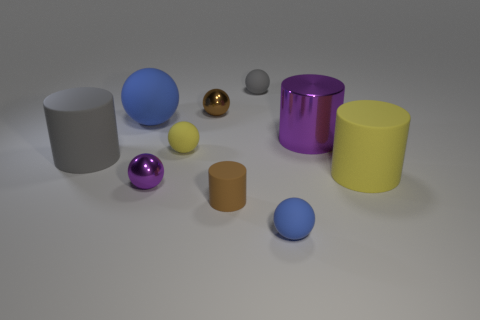What number of other things are the same material as the purple sphere?
Your answer should be compact. 2. The brown thing in front of the gray rubber thing left of the metallic object that is in front of the large yellow matte object is what shape?
Your answer should be very brief. Cylinder. Is the number of big gray matte cylinders on the right side of the tiny rubber cylinder less than the number of large cylinders that are behind the small yellow rubber ball?
Provide a succinct answer. Yes. Are there any big objects that have the same color as the metallic cylinder?
Provide a short and direct response. No. Is the material of the small cylinder the same as the small ball behind the tiny brown metal ball?
Your response must be concise. Yes. There is a matte cylinder on the right side of the small blue ball; are there any large purple things right of it?
Your answer should be compact. No. The small thing that is left of the small gray rubber ball and in front of the tiny purple metallic ball is what color?
Your answer should be compact. Brown. The purple ball has what size?
Provide a succinct answer. Small. What number of yellow cylinders are the same size as the yellow rubber ball?
Provide a short and direct response. 0. Is the material of the sphere that is in front of the small brown matte cylinder the same as the cylinder that is to the left of the small yellow object?
Your answer should be very brief. Yes. 